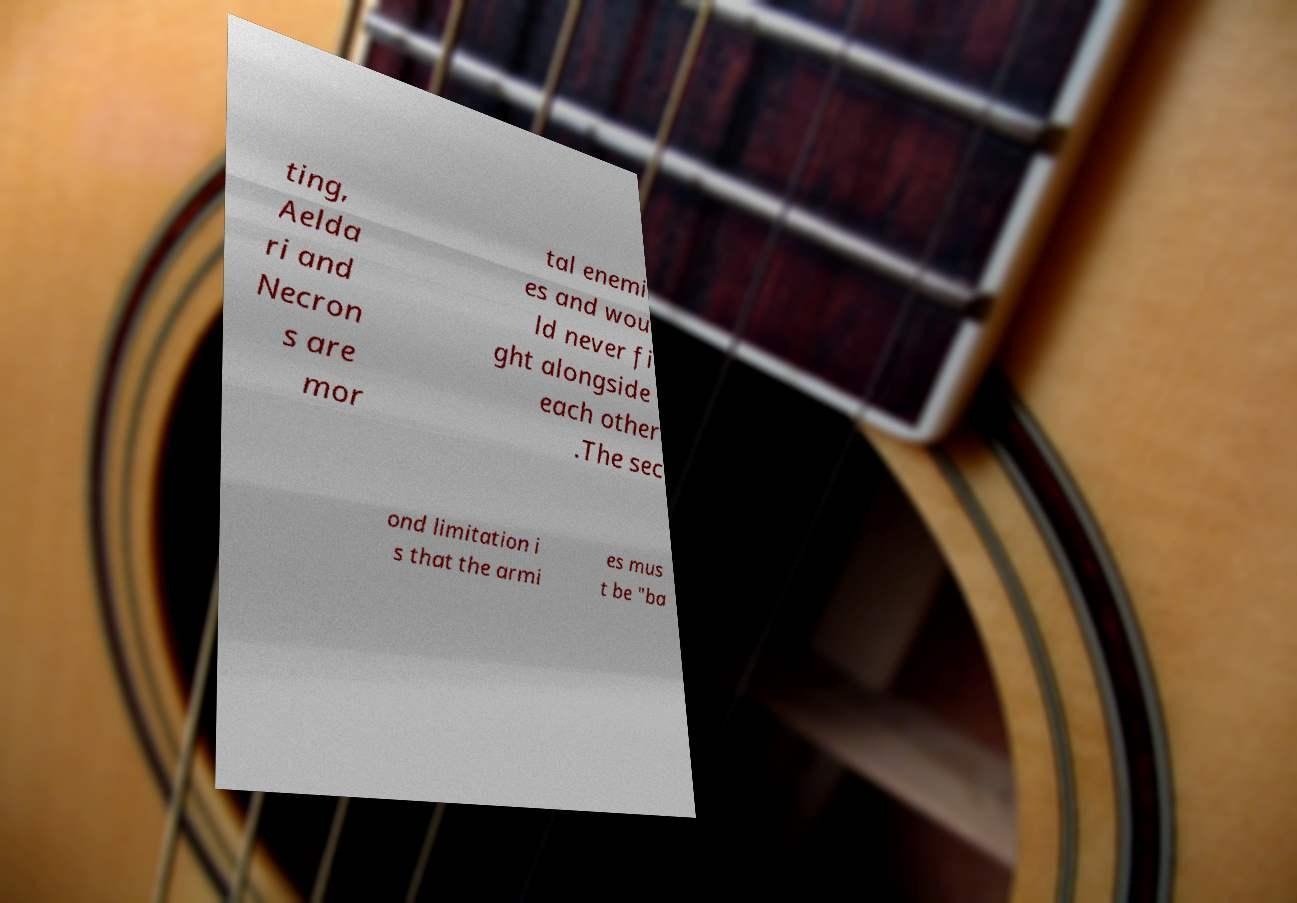I need the written content from this picture converted into text. Can you do that? ting, Aelda ri and Necron s are mor tal enemi es and wou ld never fi ght alongside each other .The sec ond limitation i s that the armi es mus t be "ba 